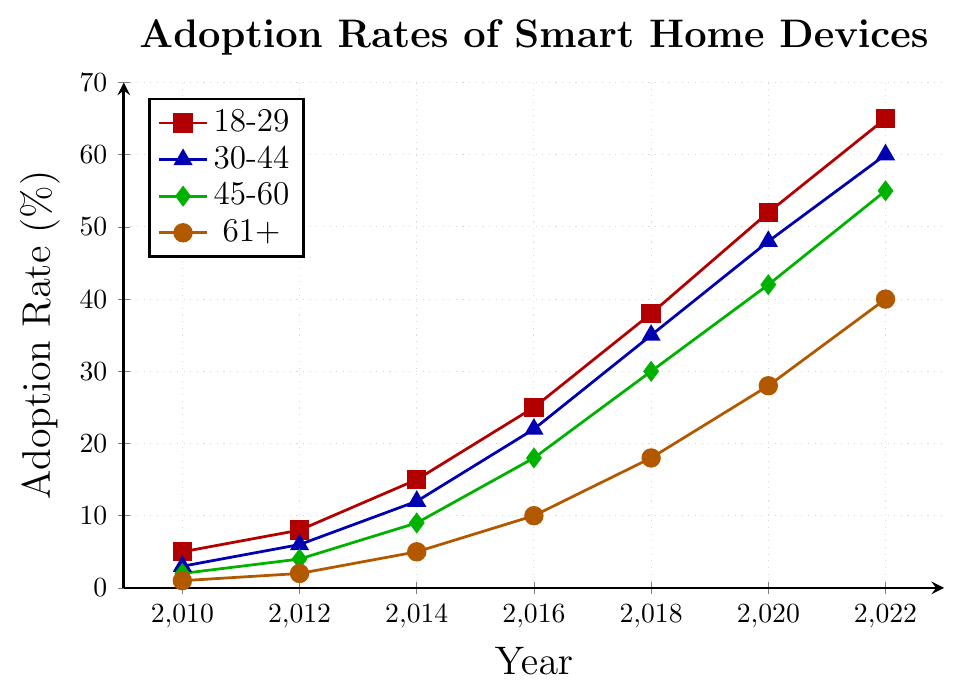What is the trend in the adoption rates of smart home devices for the 18-29 age group from 2010 to 2022? The trend is increasing over time. In 2010, it was 5%, and it progressively increased, reaching 65% by 2022.
Answer: Increasing Which age group had the lowest adoption rate in 2010 and what was that rate? The age group 61+ had the lowest adoption rate in 2010, with 1%.
Answer: 61+, 1% How much did the adoption rate for the 30-44 age group increase from 2014 to 2022? From the figure, the adoption rate for 30-44 was 12% in 2014 and 60% in 2022. The increase is 60% - 12% = 48%.
Answer: 48% Between which consecutive years did the 45-60 age group see the highest increase in adoption rate? The 45-60 age group had the highest increase between 2016 and 2018. The rate increased from 18% to 30%, which is a 12% increase.
Answer: 2016 and 2018 By how much did the adoption rate for the 61+ age group change from 2016 to 2020? In 2016, the adoption rate was 10%, and in 2020, it was 28%. The change is 28% - 10% = 18%.
Answer: 18% Which age group had the highest adoption rate in 2022, and what was the rate? The 18-29 age group had the highest adoption rate in 2022 at 65%.
Answer: 18-29, 65% Compare the adoption rates of the 18-29 and the 45-60 age groups in 2020. Which group had a higher rate and by how much? In 2020, the 18-29 group had a rate of 52%, while the 45-60 group had 42%. The 18-29 group had a higher rate by 52% - 42% = 10%.
Answer: 18-29, 10% Calculate the average adoption rate of smart home devices for the 30-44 age group from 2010 to 2022. The adoption rates for 30-44 are 3%, 6%, 12%, 22%, 35%, 48%, and 60%. The sum is 186%, and there are 7 data points. The average is 186% / 7 ≈ 26.57%.
Answer: 26.57% Identify the age group with the smallest increase in adoption rate from 2018 to 2022. The age group 61+ had the smallest increase, from 18% in 2018 to 40% in 2022, which is an increase of 22%.
Answer: 61+ What was the difference in the adoption rates between the 18-29 and 61+ age groups in 2014? In 2014, the adoption rate for 18-29 was 15% and for 61+ it was 5%. The difference is 15% - 5% = 10%.
Answer: 10% 